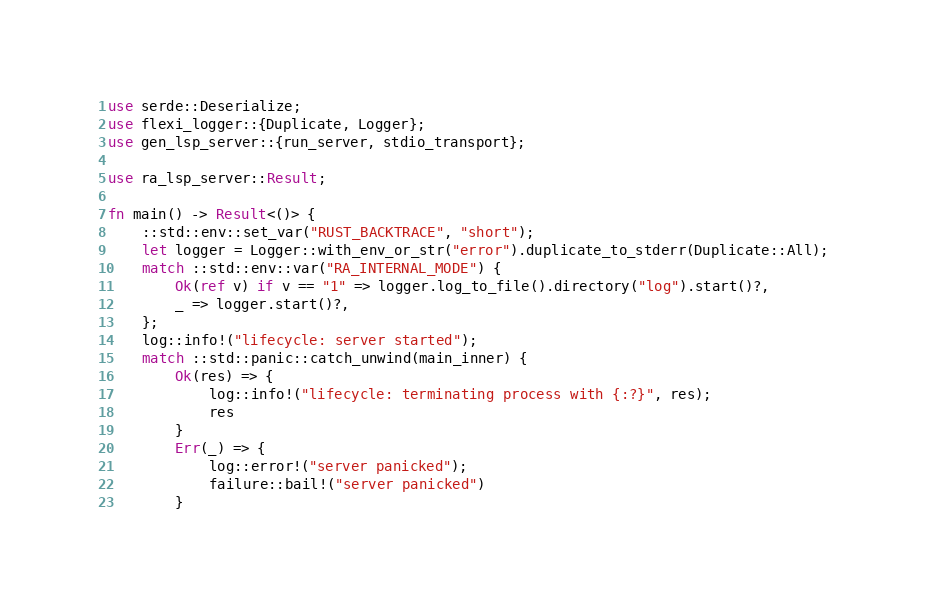<code> <loc_0><loc_0><loc_500><loc_500><_Rust_>use serde::Deserialize;
use flexi_logger::{Duplicate, Logger};
use gen_lsp_server::{run_server, stdio_transport};

use ra_lsp_server::Result;

fn main() -> Result<()> {
    ::std::env::set_var("RUST_BACKTRACE", "short");
    let logger = Logger::with_env_or_str("error").duplicate_to_stderr(Duplicate::All);
    match ::std::env::var("RA_INTERNAL_MODE") {
        Ok(ref v) if v == "1" => logger.log_to_file().directory("log").start()?,
        _ => logger.start()?,
    };
    log::info!("lifecycle: server started");
    match ::std::panic::catch_unwind(main_inner) {
        Ok(res) => {
            log::info!("lifecycle: terminating process with {:?}", res);
            res
        }
        Err(_) => {
            log::error!("server panicked");
            failure::bail!("server panicked")
        }</code> 